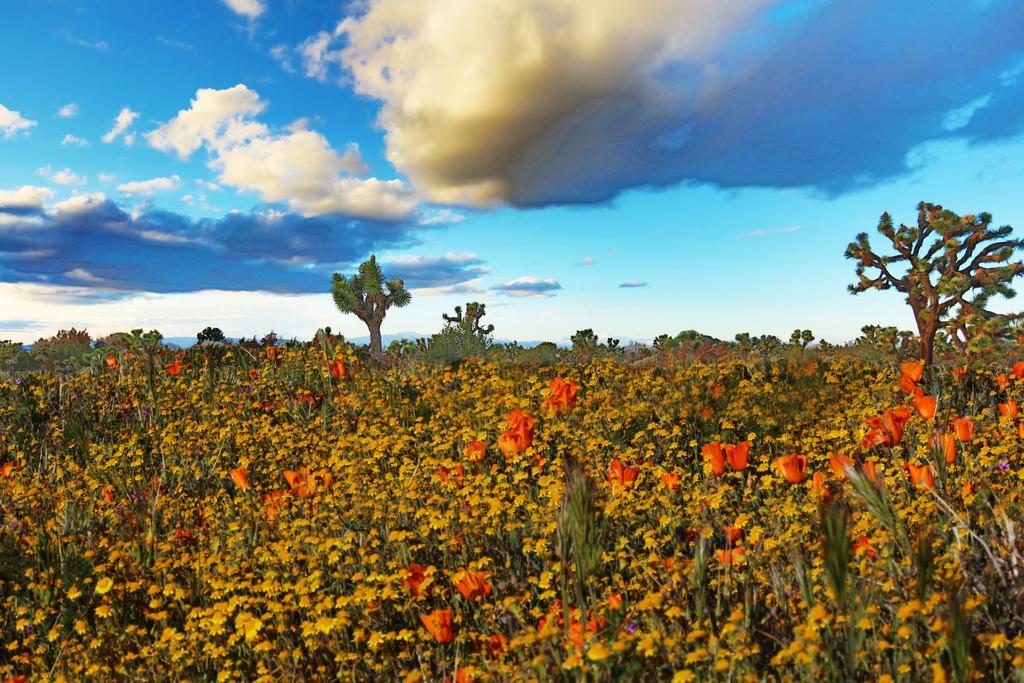In one or two sentences, can you explain what this image depicts? This is an animated picture. In the foreground of the picture there are plants and flowers. In the center of the picture there are trees and plants. Sky is bit cloudy. 